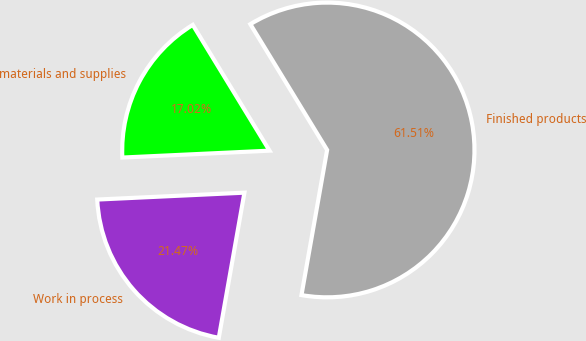<chart> <loc_0><loc_0><loc_500><loc_500><pie_chart><fcel>materials and supplies<fcel>Work in process<fcel>Finished products<nl><fcel>17.02%<fcel>21.47%<fcel>61.5%<nl></chart> 